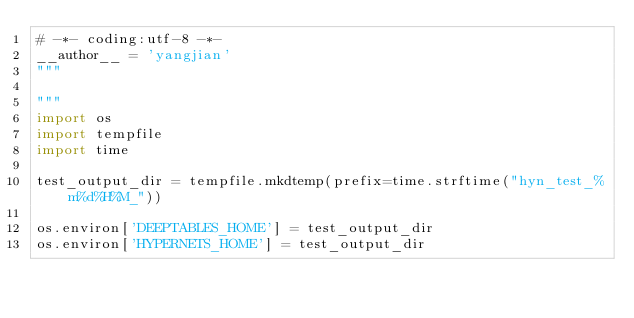<code> <loc_0><loc_0><loc_500><loc_500><_Python_># -*- coding:utf-8 -*-
__author__ = 'yangjian'
"""

"""
import os
import tempfile
import time

test_output_dir = tempfile.mkdtemp(prefix=time.strftime("hyn_test_%m%d%H%M_"))

os.environ['DEEPTABLES_HOME'] = test_output_dir
os.environ['HYPERNETS_HOME'] = test_output_dir
</code> 